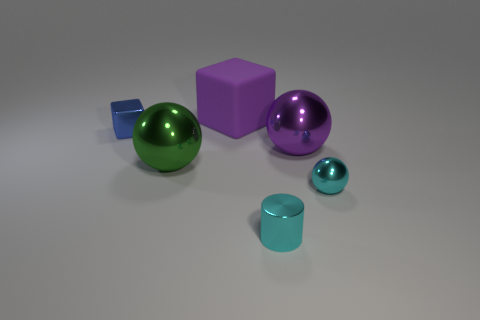Subtract all small metallic balls. How many balls are left? 2 Add 2 small brown shiny cylinders. How many objects exist? 8 Subtract all cylinders. How many objects are left? 5 Add 5 green metallic spheres. How many green metallic spheres exist? 6 Subtract 0 blue cylinders. How many objects are left? 6 Subtract all red blocks. Subtract all brown spheres. How many blocks are left? 2 Subtract all cubes. Subtract all purple matte objects. How many objects are left? 3 Add 4 small metal cylinders. How many small metal cylinders are left? 5 